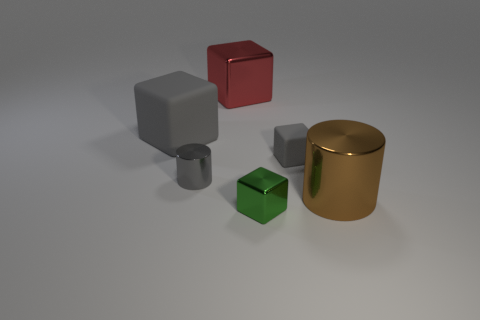Does the small gray object to the left of the tiny green block have the same shape as the large shiny object that is left of the brown metal cylinder?
Offer a very short reply. No. How many objects are big blue cylinders or tiny metallic blocks?
Make the answer very short. 1. What material is the small object that is to the right of the thing in front of the large metallic cylinder?
Offer a very short reply. Rubber. Is there a big object of the same color as the big metallic cylinder?
Ensure brevity in your answer.  No. There is a shiny cylinder that is the same size as the green cube; what is its color?
Ensure brevity in your answer.  Gray. There is a cube that is in front of the gray cube on the right side of the metal cube that is behind the tiny green metallic cube; what is it made of?
Your answer should be very brief. Metal. Is the color of the tiny metal cylinder the same as the metallic block on the right side of the big red metallic block?
Offer a terse response. No. What number of things are matte blocks on the left side of the red thing or gray matte things that are on the left side of the big red object?
Keep it short and to the point. 1. There is a big object that is in front of the matte cube that is behind the small gray rubber thing; what shape is it?
Make the answer very short. Cylinder. Is there a big yellow cylinder made of the same material as the small green cube?
Ensure brevity in your answer.  No. 